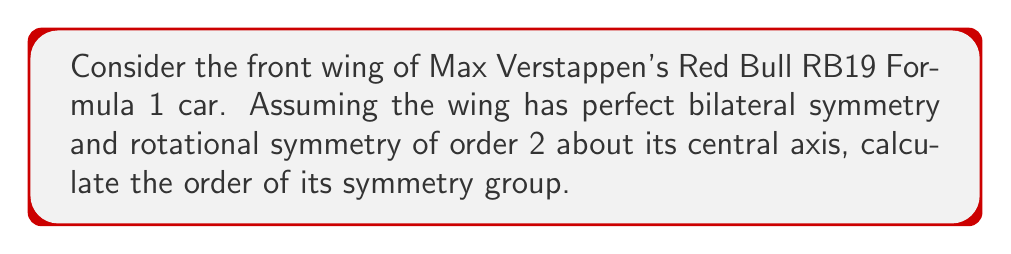Help me with this question. Let's approach this step-by-step:

1) First, we need to identify the symmetries of the front wing:
   a) Bilateral symmetry: reflection across the vertical plane bisecting the wing
   b) Rotational symmetry of order 2 about the central axis

2) These symmetries form a group. Let's call the reflection $r$ and the 180° rotation $s$.

3) The elements of this group are:
   - Identity element (e): do nothing
   - Reflection (r)
   - 180° rotation (s)
   - Reflection followed by 180° rotation (rs), which is equivalent to (sr)

4) We can verify that these form a group:
   - Closure: Combining any two of these operations results in one of the four
   - Associativity: Always true for geometric transformations
   - Identity: The identity element e exists
   - Inverse: Each element is its own inverse (e.g., $r^2 = e$, $s^2 = e$)

5) This group is isomorphic to the Klein four-group, $V_4$ or $C_2 \times C_2$.

6) The order of a group is the number of elements it contains.

Therefore, the order of this symmetry group is 4.
Answer: 4 